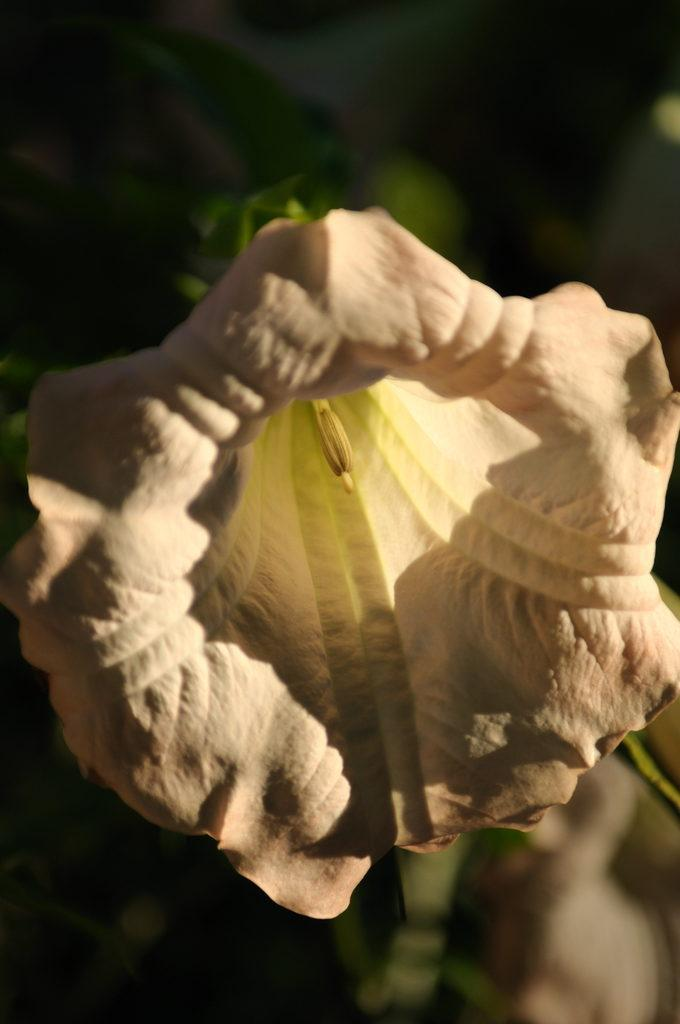What type of flower is present in the image? There is a white color flower in the image. How many spiders are crawling on the ship in the image? There is no ship or spiders present in the image; it features a white color flower. What time of day is depicted in the image? The time of day cannot be determined from the image, as it only shows a white color flower. 